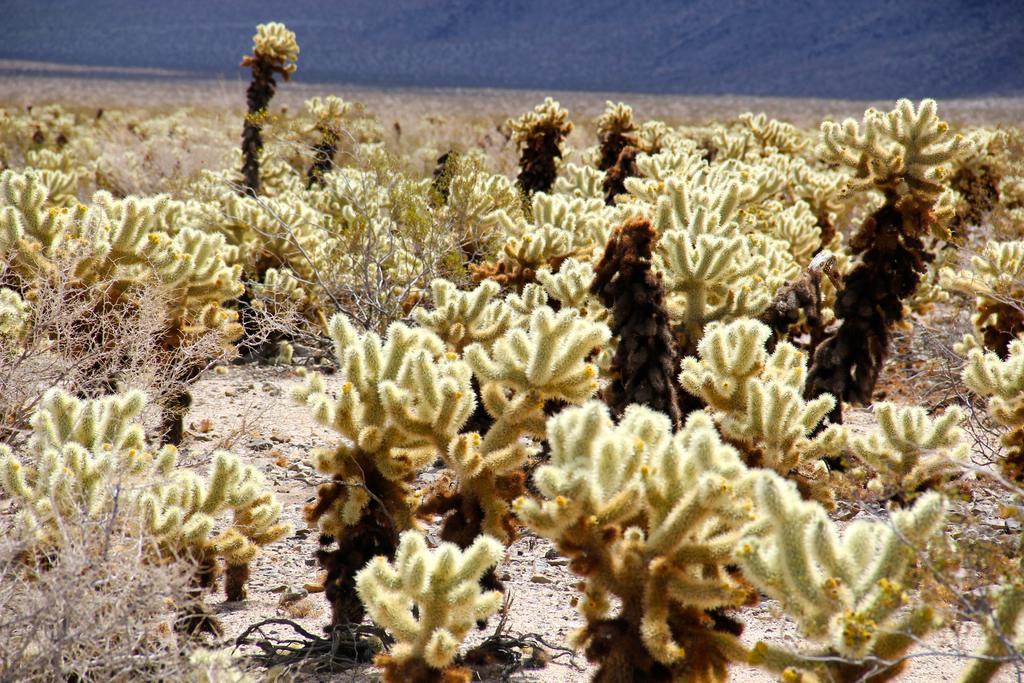Could you give a brief overview of what you see in this image? This image consists of small plants. At the bottom, there is ground. In the background, there is water. And there are dried plants in this image. 